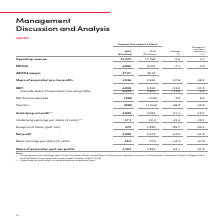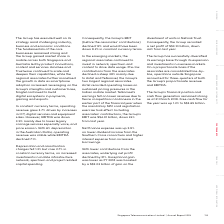According to Singapore Telecommunications's financial document, Why did operating revenue increase? increases in ICT, digital services and equipment sales. The document states: "ency terms, operating revenue grew 3.7% driven by increases in ICT, digital services and equipment sales. However, EBITDA was down 3.9% mainly due to ..." Also, What was the free cash flow for the year? According to the financial document, S$3.65 billion. The relevant text states: "h 2019. Free cash ﬂow for the year was up 1.2% to S$3.65 billion...." Also, Who are the group's two largest regional associates? The document shows two values: Airtel and Telkomsel. From the document: "tes declined a steep 38% mainly due to Airtel and Telkomsel, the Group’s two largest regional associates. Airtel recorded operating losses on sustaine..." Also, can you calculate: What is the % change in EBITDA margin from 2018 to 2019? Based on the calculation: 27% - 29.2% , the result is -2.2 (percentage). This is based on the information: "EBITDA margin 27.0% 29.2% Share of associates’ pre-tax proﬁts 1,536 2,461 -37.6 -36.2 EBITDA margin 27.0% 29.2% Share of associates’ pre-tax proﬁts 1,536 2,461 -37.6 -36.2..." The key data points involved are: 27, 29.2. Also, can you calculate: What is the change in net profit from 2018 to 2019 in absolute numbers? Based on the calculation: 3,095 - 5,473 , the result is -2378 (in millions). This is based on the information: "items (post-tax) 270 1,880 -85.7 -85.2 Net proﬁt 3,095 5,473 -43.5 -41.8 (post-tax) 270 1,880 -85.7 -85.2 Net proﬁt 3,095 5,473 -43.5 -41.8..." The key data points involved are: 3,095, 5,473. Additionally, Which year (2018 or 2019) had higher basic earnings per share? According to the financial document, 2018. The relevant text states: "2019 (S$ million) 2018 (S$ million) Change (%)..." 